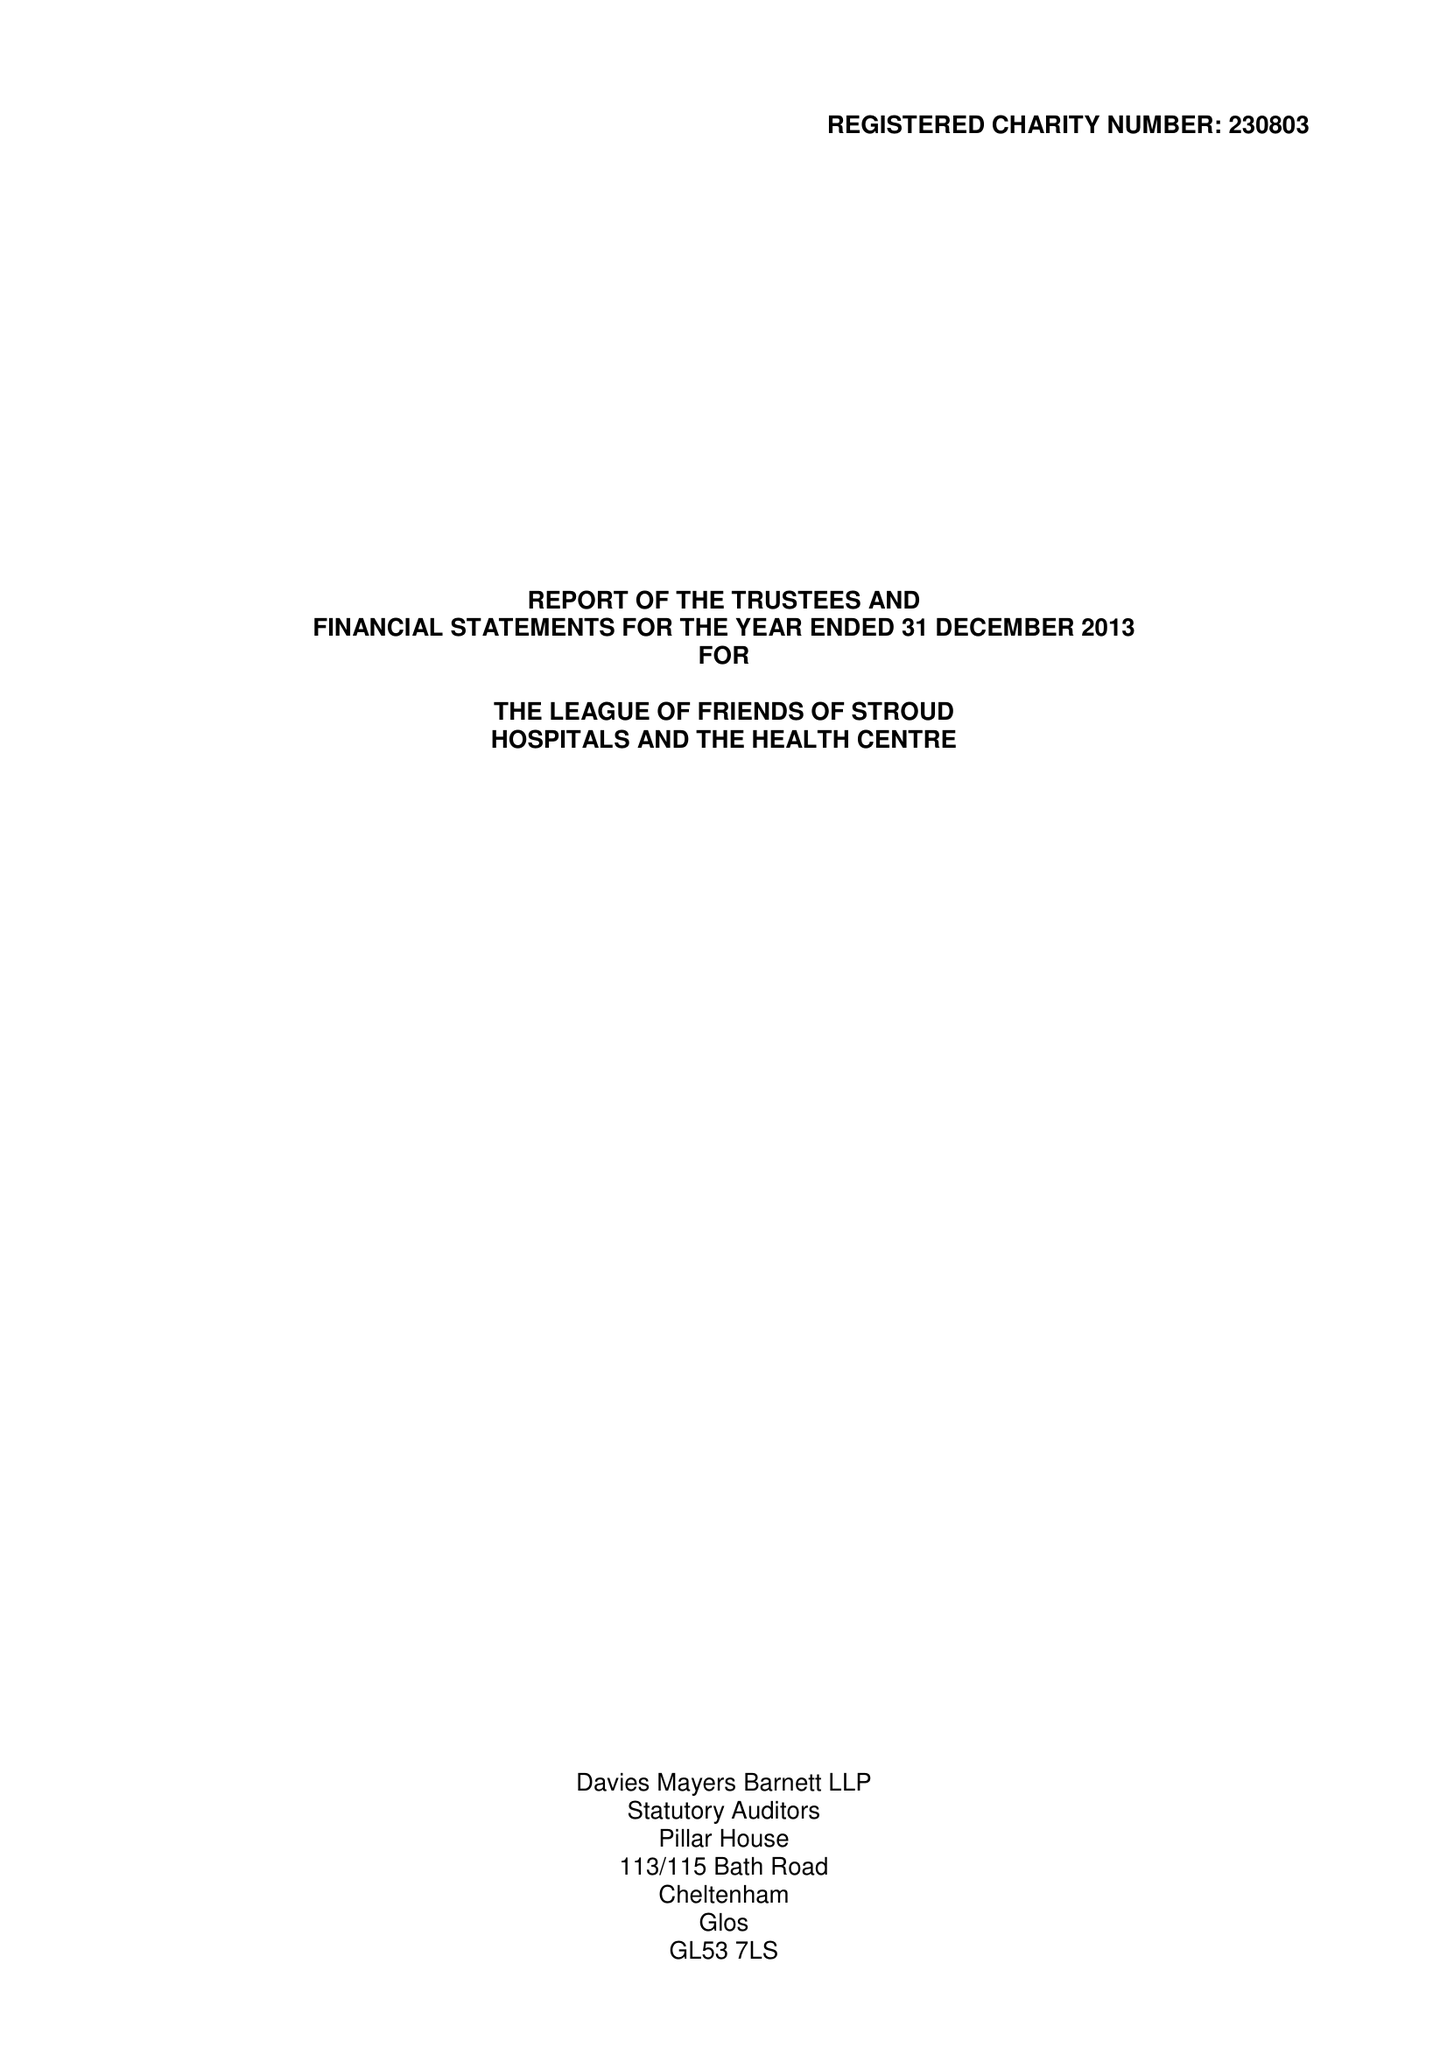What is the value for the address__post_town?
Answer the question using a single word or phrase. STROUD 